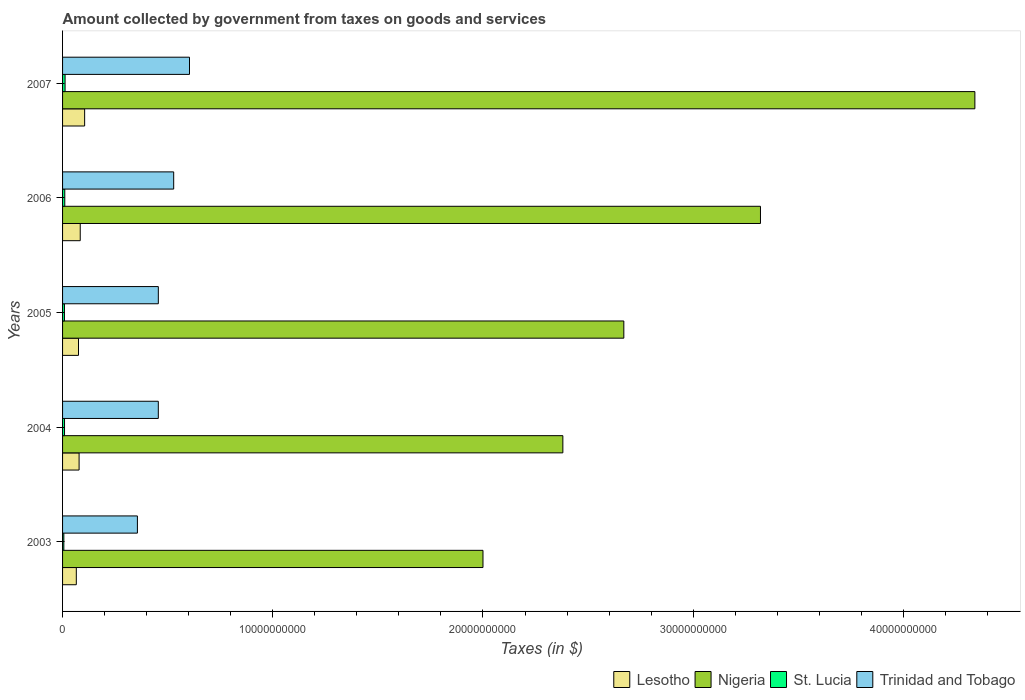How many different coloured bars are there?
Your response must be concise. 4. Are the number of bars on each tick of the Y-axis equal?
Provide a succinct answer. Yes. How many bars are there on the 3rd tick from the bottom?
Ensure brevity in your answer.  4. What is the label of the 4th group of bars from the top?
Make the answer very short. 2004. In how many cases, is the number of bars for a given year not equal to the number of legend labels?
Your answer should be very brief. 0. What is the amount collected by government from taxes on goods and services in St. Lucia in 2005?
Offer a terse response. 8.95e+07. Across all years, what is the maximum amount collected by government from taxes on goods and services in Nigeria?
Your answer should be very brief. 4.34e+1. Across all years, what is the minimum amount collected by government from taxes on goods and services in Trinidad and Tobago?
Ensure brevity in your answer.  3.56e+09. In which year was the amount collected by government from taxes on goods and services in Trinidad and Tobago maximum?
Offer a very short reply. 2007. What is the total amount collected by government from taxes on goods and services in St. Lucia in the graph?
Keep it short and to the point. 4.69e+08. What is the difference between the amount collected by government from taxes on goods and services in St. Lucia in 2006 and that in 2007?
Keep it short and to the point. -1.41e+07. What is the difference between the amount collected by government from taxes on goods and services in Trinidad and Tobago in 2004 and the amount collected by government from taxes on goods and services in St. Lucia in 2005?
Your answer should be very brief. 4.47e+09. What is the average amount collected by government from taxes on goods and services in Trinidad and Tobago per year?
Give a very brief answer. 4.80e+09. In the year 2005, what is the difference between the amount collected by government from taxes on goods and services in Trinidad and Tobago and amount collected by government from taxes on goods and services in Lesotho?
Offer a terse response. 3.80e+09. In how many years, is the amount collected by government from taxes on goods and services in Lesotho greater than 20000000000 $?
Provide a short and direct response. 0. What is the ratio of the amount collected by government from taxes on goods and services in Nigeria in 2004 to that in 2007?
Keep it short and to the point. 0.55. Is the amount collected by government from taxes on goods and services in St. Lucia in 2006 less than that in 2007?
Your answer should be very brief. Yes. What is the difference between the highest and the second highest amount collected by government from taxes on goods and services in Lesotho?
Provide a succinct answer. 2.10e+08. What is the difference between the highest and the lowest amount collected by government from taxes on goods and services in St. Lucia?
Give a very brief answer. 5.90e+07. In how many years, is the amount collected by government from taxes on goods and services in Nigeria greater than the average amount collected by government from taxes on goods and services in Nigeria taken over all years?
Your answer should be very brief. 2. What does the 4th bar from the top in 2006 represents?
Keep it short and to the point. Lesotho. What does the 1st bar from the bottom in 2005 represents?
Provide a short and direct response. Lesotho. Is it the case that in every year, the sum of the amount collected by government from taxes on goods and services in St. Lucia and amount collected by government from taxes on goods and services in Trinidad and Tobago is greater than the amount collected by government from taxes on goods and services in Nigeria?
Your response must be concise. No. What is the difference between two consecutive major ticks on the X-axis?
Your response must be concise. 1.00e+1. Are the values on the major ticks of X-axis written in scientific E-notation?
Provide a short and direct response. No. Does the graph contain any zero values?
Make the answer very short. No. Does the graph contain grids?
Ensure brevity in your answer.  No. How are the legend labels stacked?
Your response must be concise. Horizontal. What is the title of the graph?
Offer a very short reply. Amount collected by government from taxes on goods and services. Does "Lebanon" appear as one of the legend labels in the graph?
Keep it short and to the point. No. What is the label or title of the X-axis?
Your answer should be very brief. Taxes (in $). What is the Taxes (in $) in Lesotho in 2003?
Your response must be concise. 6.54e+08. What is the Taxes (in $) in St. Lucia in 2003?
Provide a short and direct response. 6.07e+07. What is the Taxes (in $) of Trinidad and Tobago in 2003?
Your response must be concise. 3.56e+09. What is the Taxes (in $) of Lesotho in 2004?
Provide a succinct answer. 7.86e+08. What is the Taxes (in $) of Nigeria in 2004?
Make the answer very short. 2.38e+1. What is the Taxes (in $) in St. Lucia in 2004?
Your response must be concise. 9.33e+07. What is the Taxes (in $) of Trinidad and Tobago in 2004?
Your answer should be very brief. 4.55e+09. What is the Taxes (in $) of Lesotho in 2005?
Your answer should be compact. 7.58e+08. What is the Taxes (in $) of Nigeria in 2005?
Provide a short and direct response. 2.67e+1. What is the Taxes (in $) in St. Lucia in 2005?
Provide a succinct answer. 8.95e+07. What is the Taxes (in $) in Trinidad and Tobago in 2005?
Offer a very short reply. 4.56e+09. What is the Taxes (in $) in Lesotho in 2006?
Offer a very short reply. 8.40e+08. What is the Taxes (in $) of Nigeria in 2006?
Your answer should be very brief. 3.32e+1. What is the Taxes (in $) in St. Lucia in 2006?
Your answer should be compact. 1.06e+08. What is the Taxes (in $) in Trinidad and Tobago in 2006?
Offer a terse response. 5.29e+09. What is the Taxes (in $) in Lesotho in 2007?
Keep it short and to the point. 1.05e+09. What is the Taxes (in $) of Nigeria in 2007?
Give a very brief answer. 4.34e+1. What is the Taxes (in $) of St. Lucia in 2007?
Make the answer very short. 1.20e+08. What is the Taxes (in $) of Trinidad and Tobago in 2007?
Offer a very short reply. 6.04e+09. Across all years, what is the maximum Taxes (in $) in Lesotho?
Give a very brief answer. 1.05e+09. Across all years, what is the maximum Taxes (in $) in Nigeria?
Make the answer very short. 4.34e+1. Across all years, what is the maximum Taxes (in $) of St. Lucia?
Keep it short and to the point. 1.20e+08. Across all years, what is the maximum Taxes (in $) of Trinidad and Tobago?
Your answer should be very brief. 6.04e+09. Across all years, what is the minimum Taxes (in $) in Lesotho?
Keep it short and to the point. 6.54e+08. Across all years, what is the minimum Taxes (in $) of St. Lucia?
Your response must be concise. 6.07e+07. Across all years, what is the minimum Taxes (in $) in Trinidad and Tobago?
Ensure brevity in your answer.  3.56e+09. What is the total Taxes (in $) of Lesotho in the graph?
Provide a succinct answer. 4.09e+09. What is the total Taxes (in $) in Nigeria in the graph?
Your response must be concise. 1.47e+11. What is the total Taxes (in $) in St. Lucia in the graph?
Keep it short and to the point. 4.69e+08. What is the total Taxes (in $) of Trinidad and Tobago in the graph?
Provide a short and direct response. 2.40e+1. What is the difference between the Taxes (in $) of Lesotho in 2003 and that in 2004?
Keep it short and to the point. -1.33e+08. What is the difference between the Taxes (in $) in Nigeria in 2003 and that in 2004?
Your answer should be compact. -3.80e+09. What is the difference between the Taxes (in $) in St. Lucia in 2003 and that in 2004?
Your response must be concise. -3.26e+07. What is the difference between the Taxes (in $) in Trinidad and Tobago in 2003 and that in 2004?
Offer a very short reply. -9.94e+08. What is the difference between the Taxes (in $) of Lesotho in 2003 and that in 2005?
Your answer should be very brief. -1.05e+08. What is the difference between the Taxes (in $) of Nigeria in 2003 and that in 2005?
Your answer should be compact. -6.70e+09. What is the difference between the Taxes (in $) of St. Lucia in 2003 and that in 2005?
Your response must be concise. -2.88e+07. What is the difference between the Taxes (in $) of Trinidad and Tobago in 2003 and that in 2005?
Keep it short and to the point. -9.95e+08. What is the difference between the Taxes (in $) in Lesotho in 2003 and that in 2006?
Your answer should be very brief. -1.87e+08. What is the difference between the Taxes (in $) in Nigeria in 2003 and that in 2006?
Provide a short and direct response. -1.32e+1. What is the difference between the Taxes (in $) in St. Lucia in 2003 and that in 2006?
Offer a very short reply. -4.49e+07. What is the difference between the Taxes (in $) of Trinidad and Tobago in 2003 and that in 2006?
Ensure brevity in your answer.  -1.73e+09. What is the difference between the Taxes (in $) of Lesotho in 2003 and that in 2007?
Keep it short and to the point. -3.96e+08. What is the difference between the Taxes (in $) in Nigeria in 2003 and that in 2007?
Offer a very short reply. -2.34e+1. What is the difference between the Taxes (in $) in St. Lucia in 2003 and that in 2007?
Make the answer very short. -5.90e+07. What is the difference between the Taxes (in $) in Trinidad and Tobago in 2003 and that in 2007?
Your answer should be compact. -2.48e+09. What is the difference between the Taxes (in $) in Lesotho in 2004 and that in 2005?
Keep it short and to the point. 2.80e+07. What is the difference between the Taxes (in $) in Nigeria in 2004 and that in 2005?
Make the answer very short. -2.90e+09. What is the difference between the Taxes (in $) in St. Lucia in 2004 and that in 2005?
Your answer should be compact. 3.80e+06. What is the difference between the Taxes (in $) of Trinidad and Tobago in 2004 and that in 2005?
Your answer should be compact. -1.20e+06. What is the difference between the Taxes (in $) in Lesotho in 2004 and that in 2006?
Provide a short and direct response. -5.39e+07. What is the difference between the Taxes (in $) in Nigeria in 2004 and that in 2006?
Provide a short and direct response. -9.40e+09. What is the difference between the Taxes (in $) in St. Lucia in 2004 and that in 2006?
Give a very brief answer. -1.23e+07. What is the difference between the Taxes (in $) of Trinidad and Tobago in 2004 and that in 2006?
Your answer should be compact. -7.32e+08. What is the difference between the Taxes (in $) in Lesotho in 2004 and that in 2007?
Ensure brevity in your answer.  -2.63e+08. What is the difference between the Taxes (in $) of Nigeria in 2004 and that in 2007?
Provide a short and direct response. -1.96e+1. What is the difference between the Taxes (in $) of St. Lucia in 2004 and that in 2007?
Provide a succinct answer. -2.64e+07. What is the difference between the Taxes (in $) of Trinidad and Tobago in 2004 and that in 2007?
Your response must be concise. -1.48e+09. What is the difference between the Taxes (in $) of Lesotho in 2005 and that in 2006?
Provide a short and direct response. -8.19e+07. What is the difference between the Taxes (in $) in Nigeria in 2005 and that in 2006?
Offer a terse response. -6.50e+09. What is the difference between the Taxes (in $) in St. Lucia in 2005 and that in 2006?
Your answer should be very brief. -1.61e+07. What is the difference between the Taxes (in $) in Trinidad and Tobago in 2005 and that in 2006?
Your answer should be compact. -7.30e+08. What is the difference between the Taxes (in $) of Lesotho in 2005 and that in 2007?
Offer a terse response. -2.92e+08. What is the difference between the Taxes (in $) in Nigeria in 2005 and that in 2007?
Provide a short and direct response. -1.67e+1. What is the difference between the Taxes (in $) in St. Lucia in 2005 and that in 2007?
Ensure brevity in your answer.  -3.02e+07. What is the difference between the Taxes (in $) of Trinidad and Tobago in 2005 and that in 2007?
Provide a short and direct response. -1.48e+09. What is the difference between the Taxes (in $) of Lesotho in 2006 and that in 2007?
Provide a succinct answer. -2.10e+08. What is the difference between the Taxes (in $) in Nigeria in 2006 and that in 2007?
Your response must be concise. -1.02e+1. What is the difference between the Taxes (in $) of St. Lucia in 2006 and that in 2007?
Provide a short and direct response. -1.41e+07. What is the difference between the Taxes (in $) of Trinidad and Tobago in 2006 and that in 2007?
Your answer should be compact. -7.52e+08. What is the difference between the Taxes (in $) in Lesotho in 2003 and the Taxes (in $) in Nigeria in 2004?
Make the answer very short. -2.31e+1. What is the difference between the Taxes (in $) of Lesotho in 2003 and the Taxes (in $) of St. Lucia in 2004?
Offer a terse response. 5.60e+08. What is the difference between the Taxes (in $) of Lesotho in 2003 and the Taxes (in $) of Trinidad and Tobago in 2004?
Keep it short and to the point. -3.90e+09. What is the difference between the Taxes (in $) in Nigeria in 2003 and the Taxes (in $) in St. Lucia in 2004?
Give a very brief answer. 1.99e+1. What is the difference between the Taxes (in $) of Nigeria in 2003 and the Taxes (in $) of Trinidad and Tobago in 2004?
Provide a succinct answer. 1.54e+1. What is the difference between the Taxes (in $) of St. Lucia in 2003 and the Taxes (in $) of Trinidad and Tobago in 2004?
Give a very brief answer. -4.49e+09. What is the difference between the Taxes (in $) of Lesotho in 2003 and the Taxes (in $) of Nigeria in 2005?
Offer a terse response. -2.60e+1. What is the difference between the Taxes (in $) of Lesotho in 2003 and the Taxes (in $) of St. Lucia in 2005?
Offer a terse response. 5.64e+08. What is the difference between the Taxes (in $) of Lesotho in 2003 and the Taxes (in $) of Trinidad and Tobago in 2005?
Provide a succinct answer. -3.90e+09. What is the difference between the Taxes (in $) of Nigeria in 2003 and the Taxes (in $) of St. Lucia in 2005?
Give a very brief answer. 1.99e+1. What is the difference between the Taxes (in $) of Nigeria in 2003 and the Taxes (in $) of Trinidad and Tobago in 2005?
Offer a terse response. 1.54e+1. What is the difference between the Taxes (in $) in St. Lucia in 2003 and the Taxes (in $) in Trinidad and Tobago in 2005?
Your response must be concise. -4.50e+09. What is the difference between the Taxes (in $) in Lesotho in 2003 and the Taxes (in $) in Nigeria in 2006?
Offer a terse response. -3.25e+1. What is the difference between the Taxes (in $) in Lesotho in 2003 and the Taxes (in $) in St. Lucia in 2006?
Offer a very short reply. 5.48e+08. What is the difference between the Taxes (in $) in Lesotho in 2003 and the Taxes (in $) in Trinidad and Tobago in 2006?
Ensure brevity in your answer.  -4.63e+09. What is the difference between the Taxes (in $) of Nigeria in 2003 and the Taxes (in $) of St. Lucia in 2006?
Provide a succinct answer. 1.99e+1. What is the difference between the Taxes (in $) in Nigeria in 2003 and the Taxes (in $) in Trinidad and Tobago in 2006?
Offer a very short reply. 1.47e+1. What is the difference between the Taxes (in $) in St. Lucia in 2003 and the Taxes (in $) in Trinidad and Tobago in 2006?
Ensure brevity in your answer.  -5.23e+09. What is the difference between the Taxes (in $) in Lesotho in 2003 and the Taxes (in $) in Nigeria in 2007?
Keep it short and to the point. -4.27e+1. What is the difference between the Taxes (in $) of Lesotho in 2003 and the Taxes (in $) of St. Lucia in 2007?
Make the answer very short. 5.34e+08. What is the difference between the Taxes (in $) in Lesotho in 2003 and the Taxes (in $) in Trinidad and Tobago in 2007?
Provide a succinct answer. -5.38e+09. What is the difference between the Taxes (in $) of Nigeria in 2003 and the Taxes (in $) of St. Lucia in 2007?
Offer a terse response. 1.99e+1. What is the difference between the Taxes (in $) of Nigeria in 2003 and the Taxes (in $) of Trinidad and Tobago in 2007?
Your answer should be compact. 1.40e+1. What is the difference between the Taxes (in $) of St. Lucia in 2003 and the Taxes (in $) of Trinidad and Tobago in 2007?
Provide a short and direct response. -5.98e+09. What is the difference between the Taxes (in $) of Lesotho in 2004 and the Taxes (in $) of Nigeria in 2005?
Offer a very short reply. -2.59e+1. What is the difference between the Taxes (in $) of Lesotho in 2004 and the Taxes (in $) of St. Lucia in 2005?
Your response must be concise. 6.97e+08. What is the difference between the Taxes (in $) in Lesotho in 2004 and the Taxes (in $) in Trinidad and Tobago in 2005?
Your answer should be very brief. -3.77e+09. What is the difference between the Taxes (in $) of Nigeria in 2004 and the Taxes (in $) of St. Lucia in 2005?
Make the answer very short. 2.37e+1. What is the difference between the Taxes (in $) in Nigeria in 2004 and the Taxes (in $) in Trinidad and Tobago in 2005?
Offer a terse response. 1.92e+1. What is the difference between the Taxes (in $) in St. Lucia in 2004 and the Taxes (in $) in Trinidad and Tobago in 2005?
Offer a terse response. -4.46e+09. What is the difference between the Taxes (in $) in Lesotho in 2004 and the Taxes (in $) in Nigeria in 2006?
Your answer should be compact. -3.24e+1. What is the difference between the Taxes (in $) in Lesotho in 2004 and the Taxes (in $) in St. Lucia in 2006?
Provide a short and direct response. 6.81e+08. What is the difference between the Taxes (in $) of Lesotho in 2004 and the Taxes (in $) of Trinidad and Tobago in 2006?
Your response must be concise. -4.50e+09. What is the difference between the Taxes (in $) of Nigeria in 2004 and the Taxes (in $) of St. Lucia in 2006?
Provide a short and direct response. 2.37e+1. What is the difference between the Taxes (in $) of Nigeria in 2004 and the Taxes (in $) of Trinidad and Tobago in 2006?
Your response must be concise. 1.85e+1. What is the difference between the Taxes (in $) of St. Lucia in 2004 and the Taxes (in $) of Trinidad and Tobago in 2006?
Your answer should be very brief. -5.19e+09. What is the difference between the Taxes (in $) in Lesotho in 2004 and the Taxes (in $) in Nigeria in 2007?
Provide a succinct answer. -4.26e+1. What is the difference between the Taxes (in $) of Lesotho in 2004 and the Taxes (in $) of St. Lucia in 2007?
Offer a very short reply. 6.67e+08. What is the difference between the Taxes (in $) in Lesotho in 2004 and the Taxes (in $) in Trinidad and Tobago in 2007?
Provide a short and direct response. -5.25e+09. What is the difference between the Taxes (in $) in Nigeria in 2004 and the Taxes (in $) in St. Lucia in 2007?
Keep it short and to the point. 2.37e+1. What is the difference between the Taxes (in $) in Nigeria in 2004 and the Taxes (in $) in Trinidad and Tobago in 2007?
Offer a terse response. 1.78e+1. What is the difference between the Taxes (in $) in St. Lucia in 2004 and the Taxes (in $) in Trinidad and Tobago in 2007?
Provide a short and direct response. -5.94e+09. What is the difference between the Taxes (in $) of Lesotho in 2005 and the Taxes (in $) of Nigeria in 2006?
Offer a very short reply. -3.24e+1. What is the difference between the Taxes (in $) of Lesotho in 2005 and the Taxes (in $) of St. Lucia in 2006?
Offer a terse response. 6.53e+08. What is the difference between the Taxes (in $) in Lesotho in 2005 and the Taxes (in $) in Trinidad and Tobago in 2006?
Your answer should be compact. -4.53e+09. What is the difference between the Taxes (in $) in Nigeria in 2005 and the Taxes (in $) in St. Lucia in 2006?
Ensure brevity in your answer.  2.66e+1. What is the difference between the Taxes (in $) in Nigeria in 2005 and the Taxes (in $) in Trinidad and Tobago in 2006?
Your answer should be compact. 2.14e+1. What is the difference between the Taxes (in $) in St. Lucia in 2005 and the Taxes (in $) in Trinidad and Tobago in 2006?
Your response must be concise. -5.20e+09. What is the difference between the Taxes (in $) in Lesotho in 2005 and the Taxes (in $) in Nigeria in 2007?
Your answer should be compact. -4.26e+1. What is the difference between the Taxes (in $) in Lesotho in 2005 and the Taxes (in $) in St. Lucia in 2007?
Your response must be concise. 6.39e+08. What is the difference between the Taxes (in $) of Lesotho in 2005 and the Taxes (in $) of Trinidad and Tobago in 2007?
Provide a short and direct response. -5.28e+09. What is the difference between the Taxes (in $) of Nigeria in 2005 and the Taxes (in $) of St. Lucia in 2007?
Give a very brief answer. 2.66e+1. What is the difference between the Taxes (in $) in Nigeria in 2005 and the Taxes (in $) in Trinidad and Tobago in 2007?
Keep it short and to the point. 2.07e+1. What is the difference between the Taxes (in $) in St. Lucia in 2005 and the Taxes (in $) in Trinidad and Tobago in 2007?
Your answer should be compact. -5.95e+09. What is the difference between the Taxes (in $) of Lesotho in 2006 and the Taxes (in $) of Nigeria in 2007?
Make the answer very short. -4.26e+1. What is the difference between the Taxes (in $) of Lesotho in 2006 and the Taxes (in $) of St. Lucia in 2007?
Ensure brevity in your answer.  7.21e+08. What is the difference between the Taxes (in $) of Lesotho in 2006 and the Taxes (in $) of Trinidad and Tobago in 2007?
Make the answer very short. -5.20e+09. What is the difference between the Taxes (in $) in Nigeria in 2006 and the Taxes (in $) in St. Lucia in 2007?
Your response must be concise. 3.31e+1. What is the difference between the Taxes (in $) in Nigeria in 2006 and the Taxes (in $) in Trinidad and Tobago in 2007?
Keep it short and to the point. 2.72e+1. What is the difference between the Taxes (in $) of St. Lucia in 2006 and the Taxes (in $) of Trinidad and Tobago in 2007?
Make the answer very short. -5.93e+09. What is the average Taxes (in $) of Lesotho per year?
Ensure brevity in your answer.  8.18e+08. What is the average Taxes (in $) in Nigeria per year?
Offer a very short reply. 2.94e+1. What is the average Taxes (in $) in St. Lucia per year?
Provide a short and direct response. 9.38e+07. What is the average Taxes (in $) in Trinidad and Tobago per year?
Give a very brief answer. 4.80e+09. In the year 2003, what is the difference between the Taxes (in $) in Lesotho and Taxes (in $) in Nigeria?
Offer a very short reply. -1.93e+1. In the year 2003, what is the difference between the Taxes (in $) of Lesotho and Taxes (in $) of St. Lucia?
Make the answer very short. 5.93e+08. In the year 2003, what is the difference between the Taxes (in $) of Lesotho and Taxes (in $) of Trinidad and Tobago?
Make the answer very short. -2.91e+09. In the year 2003, what is the difference between the Taxes (in $) in Nigeria and Taxes (in $) in St. Lucia?
Make the answer very short. 1.99e+1. In the year 2003, what is the difference between the Taxes (in $) in Nigeria and Taxes (in $) in Trinidad and Tobago?
Your answer should be very brief. 1.64e+1. In the year 2003, what is the difference between the Taxes (in $) in St. Lucia and Taxes (in $) in Trinidad and Tobago?
Your answer should be compact. -3.50e+09. In the year 2004, what is the difference between the Taxes (in $) of Lesotho and Taxes (in $) of Nigeria?
Your answer should be compact. -2.30e+1. In the year 2004, what is the difference between the Taxes (in $) in Lesotho and Taxes (in $) in St. Lucia?
Ensure brevity in your answer.  6.93e+08. In the year 2004, what is the difference between the Taxes (in $) of Lesotho and Taxes (in $) of Trinidad and Tobago?
Your answer should be very brief. -3.77e+09. In the year 2004, what is the difference between the Taxes (in $) of Nigeria and Taxes (in $) of St. Lucia?
Offer a very short reply. 2.37e+1. In the year 2004, what is the difference between the Taxes (in $) in Nigeria and Taxes (in $) in Trinidad and Tobago?
Your answer should be very brief. 1.92e+1. In the year 2004, what is the difference between the Taxes (in $) of St. Lucia and Taxes (in $) of Trinidad and Tobago?
Provide a short and direct response. -4.46e+09. In the year 2005, what is the difference between the Taxes (in $) in Lesotho and Taxes (in $) in Nigeria?
Keep it short and to the point. -2.59e+1. In the year 2005, what is the difference between the Taxes (in $) of Lesotho and Taxes (in $) of St. Lucia?
Your response must be concise. 6.69e+08. In the year 2005, what is the difference between the Taxes (in $) in Lesotho and Taxes (in $) in Trinidad and Tobago?
Your answer should be compact. -3.80e+09. In the year 2005, what is the difference between the Taxes (in $) of Nigeria and Taxes (in $) of St. Lucia?
Your answer should be very brief. 2.66e+1. In the year 2005, what is the difference between the Taxes (in $) in Nigeria and Taxes (in $) in Trinidad and Tobago?
Provide a short and direct response. 2.21e+1. In the year 2005, what is the difference between the Taxes (in $) of St. Lucia and Taxes (in $) of Trinidad and Tobago?
Ensure brevity in your answer.  -4.47e+09. In the year 2006, what is the difference between the Taxes (in $) in Lesotho and Taxes (in $) in Nigeria?
Your response must be concise. -3.24e+1. In the year 2006, what is the difference between the Taxes (in $) of Lesotho and Taxes (in $) of St. Lucia?
Offer a terse response. 7.35e+08. In the year 2006, what is the difference between the Taxes (in $) in Lesotho and Taxes (in $) in Trinidad and Tobago?
Give a very brief answer. -4.45e+09. In the year 2006, what is the difference between the Taxes (in $) of Nigeria and Taxes (in $) of St. Lucia?
Offer a terse response. 3.31e+1. In the year 2006, what is the difference between the Taxes (in $) of Nigeria and Taxes (in $) of Trinidad and Tobago?
Provide a succinct answer. 2.79e+1. In the year 2006, what is the difference between the Taxes (in $) in St. Lucia and Taxes (in $) in Trinidad and Tobago?
Ensure brevity in your answer.  -5.18e+09. In the year 2007, what is the difference between the Taxes (in $) in Lesotho and Taxes (in $) in Nigeria?
Your answer should be very brief. -4.24e+1. In the year 2007, what is the difference between the Taxes (in $) in Lesotho and Taxes (in $) in St. Lucia?
Give a very brief answer. 9.30e+08. In the year 2007, what is the difference between the Taxes (in $) of Lesotho and Taxes (in $) of Trinidad and Tobago?
Your response must be concise. -4.99e+09. In the year 2007, what is the difference between the Taxes (in $) of Nigeria and Taxes (in $) of St. Lucia?
Your response must be concise. 4.33e+1. In the year 2007, what is the difference between the Taxes (in $) of Nigeria and Taxes (in $) of Trinidad and Tobago?
Ensure brevity in your answer.  3.74e+1. In the year 2007, what is the difference between the Taxes (in $) in St. Lucia and Taxes (in $) in Trinidad and Tobago?
Your answer should be very brief. -5.92e+09. What is the ratio of the Taxes (in $) of Lesotho in 2003 to that in 2004?
Offer a very short reply. 0.83. What is the ratio of the Taxes (in $) of Nigeria in 2003 to that in 2004?
Provide a short and direct response. 0.84. What is the ratio of the Taxes (in $) of St. Lucia in 2003 to that in 2004?
Your response must be concise. 0.65. What is the ratio of the Taxes (in $) of Trinidad and Tobago in 2003 to that in 2004?
Give a very brief answer. 0.78. What is the ratio of the Taxes (in $) of Lesotho in 2003 to that in 2005?
Provide a short and direct response. 0.86. What is the ratio of the Taxes (in $) of Nigeria in 2003 to that in 2005?
Give a very brief answer. 0.75. What is the ratio of the Taxes (in $) of St. Lucia in 2003 to that in 2005?
Offer a very short reply. 0.68. What is the ratio of the Taxes (in $) of Trinidad and Tobago in 2003 to that in 2005?
Your response must be concise. 0.78. What is the ratio of the Taxes (in $) of Lesotho in 2003 to that in 2006?
Your response must be concise. 0.78. What is the ratio of the Taxes (in $) of Nigeria in 2003 to that in 2006?
Keep it short and to the point. 0.6. What is the ratio of the Taxes (in $) in St. Lucia in 2003 to that in 2006?
Your answer should be very brief. 0.57. What is the ratio of the Taxes (in $) in Trinidad and Tobago in 2003 to that in 2006?
Your answer should be very brief. 0.67. What is the ratio of the Taxes (in $) of Lesotho in 2003 to that in 2007?
Your answer should be compact. 0.62. What is the ratio of the Taxes (in $) in Nigeria in 2003 to that in 2007?
Offer a terse response. 0.46. What is the ratio of the Taxes (in $) of St. Lucia in 2003 to that in 2007?
Ensure brevity in your answer.  0.51. What is the ratio of the Taxes (in $) in Trinidad and Tobago in 2003 to that in 2007?
Your answer should be very brief. 0.59. What is the ratio of the Taxes (in $) in Nigeria in 2004 to that in 2005?
Offer a terse response. 0.89. What is the ratio of the Taxes (in $) in St. Lucia in 2004 to that in 2005?
Make the answer very short. 1.04. What is the ratio of the Taxes (in $) of Trinidad and Tobago in 2004 to that in 2005?
Keep it short and to the point. 1. What is the ratio of the Taxes (in $) in Lesotho in 2004 to that in 2006?
Your response must be concise. 0.94. What is the ratio of the Taxes (in $) of Nigeria in 2004 to that in 2006?
Your answer should be compact. 0.72. What is the ratio of the Taxes (in $) in St. Lucia in 2004 to that in 2006?
Make the answer very short. 0.88. What is the ratio of the Taxes (in $) of Trinidad and Tobago in 2004 to that in 2006?
Give a very brief answer. 0.86. What is the ratio of the Taxes (in $) of Lesotho in 2004 to that in 2007?
Offer a very short reply. 0.75. What is the ratio of the Taxes (in $) in Nigeria in 2004 to that in 2007?
Your answer should be compact. 0.55. What is the ratio of the Taxes (in $) in St. Lucia in 2004 to that in 2007?
Your answer should be compact. 0.78. What is the ratio of the Taxes (in $) of Trinidad and Tobago in 2004 to that in 2007?
Your answer should be compact. 0.75. What is the ratio of the Taxes (in $) of Lesotho in 2005 to that in 2006?
Keep it short and to the point. 0.9. What is the ratio of the Taxes (in $) in Nigeria in 2005 to that in 2006?
Provide a succinct answer. 0.8. What is the ratio of the Taxes (in $) of St. Lucia in 2005 to that in 2006?
Keep it short and to the point. 0.85. What is the ratio of the Taxes (in $) of Trinidad and Tobago in 2005 to that in 2006?
Your answer should be compact. 0.86. What is the ratio of the Taxes (in $) of Lesotho in 2005 to that in 2007?
Your answer should be very brief. 0.72. What is the ratio of the Taxes (in $) in Nigeria in 2005 to that in 2007?
Provide a succinct answer. 0.62. What is the ratio of the Taxes (in $) of St. Lucia in 2005 to that in 2007?
Make the answer very short. 0.75. What is the ratio of the Taxes (in $) in Trinidad and Tobago in 2005 to that in 2007?
Your response must be concise. 0.75. What is the ratio of the Taxes (in $) of Lesotho in 2006 to that in 2007?
Provide a succinct answer. 0.8. What is the ratio of the Taxes (in $) of Nigeria in 2006 to that in 2007?
Provide a short and direct response. 0.77. What is the ratio of the Taxes (in $) of St. Lucia in 2006 to that in 2007?
Your response must be concise. 0.88. What is the ratio of the Taxes (in $) of Trinidad and Tobago in 2006 to that in 2007?
Make the answer very short. 0.88. What is the difference between the highest and the second highest Taxes (in $) in Lesotho?
Make the answer very short. 2.10e+08. What is the difference between the highest and the second highest Taxes (in $) in Nigeria?
Offer a very short reply. 1.02e+1. What is the difference between the highest and the second highest Taxes (in $) in St. Lucia?
Your answer should be compact. 1.41e+07. What is the difference between the highest and the second highest Taxes (in $) of Trinidad and Tobago?
Keep it short and to the point. 7.52e+08. What is the difference between the highest and the lowest Taxes (in $) of Lesotho?
Offer a very short reply. 3.96e+08. What is the difference between the highest and the lowest Taxes (in $) in Nigeria?
Your answer should be compact. 2.34e+1. What is the difference between the highest and the lowest Taxes (in $) in St. Lucia?
Provide a succinct answer. 5.90e+07. What is the difference between the highest and the lowest Taxes (in $) of Trinidad and Tobago?
Offer a terse response. 2.48e+09. 